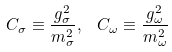<formula> <loc_0><loc_0><loc_500><loc_500>C _ { \sigma } \equiv \frac { g _ { \sigma } ^ { 2 } } { m _ { \sigma } ^ { 2 } } , \ \ C _ { \omega } \equiv \frac { g _ { \omega } ^ { 2 } } { m _ { \omega } ^ { 2 } }</formula> 